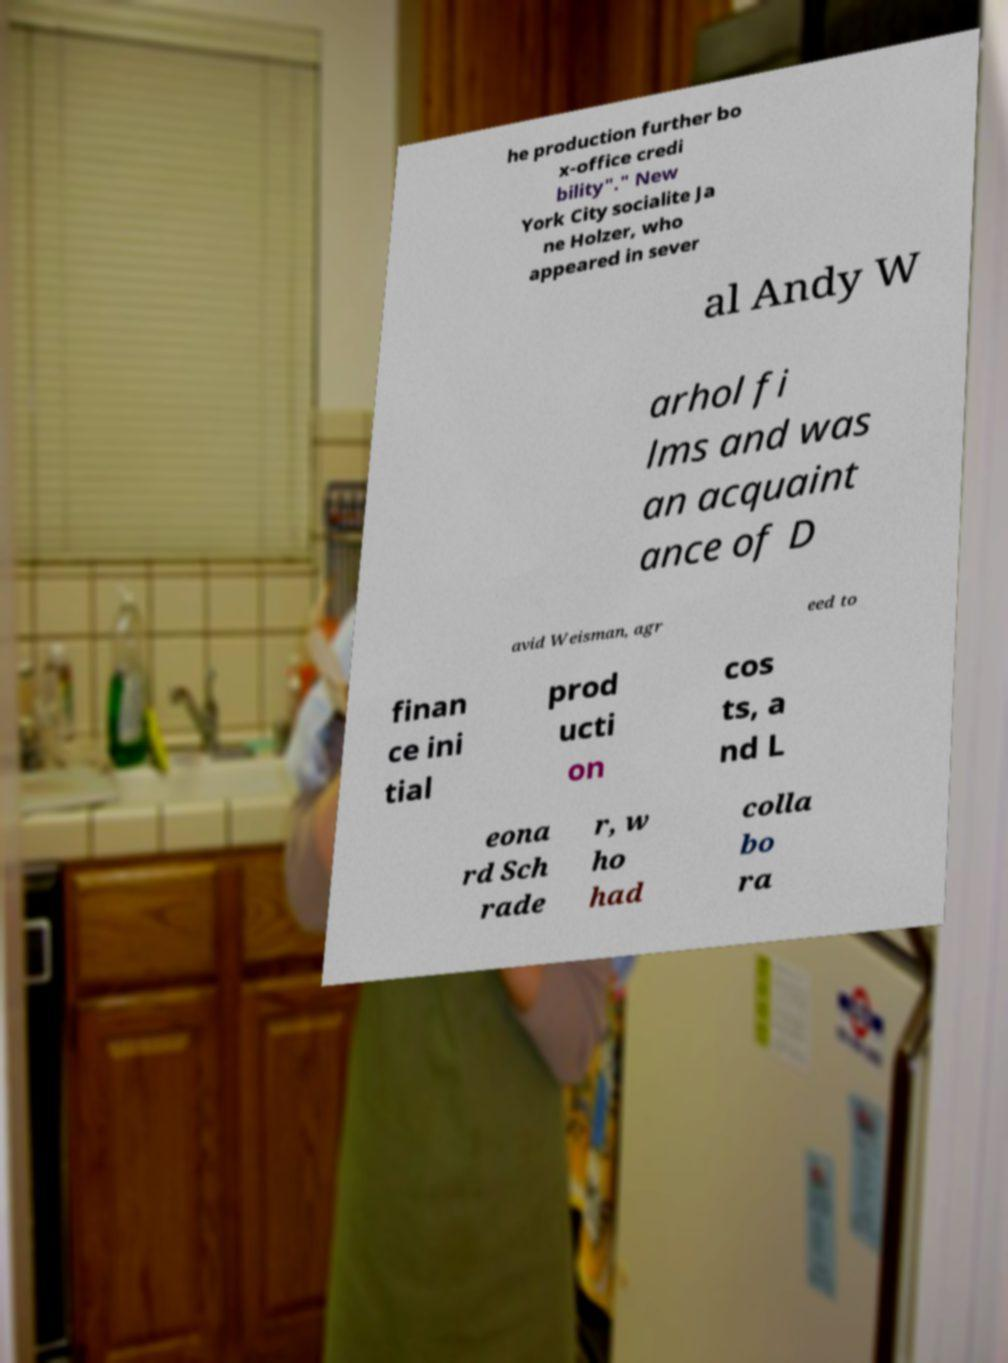Please identify and transcribe the text found in this image. he production further bo x-office credi bility"." New York City socialite Ja ne Holzer, who appeared in sever al Andy W arhol fi lms and was an acquaint ance of D avid Weisman, agr eed to finan ce ini tial prod ucti on cos ts, a nd L eona rd Sch rade r, w ho had colla bo ra 